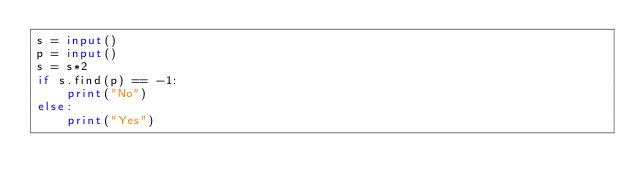Convert code to text. <code><loc_0><loc_0><loc_500><loc_500><_Python_>s = input()
p = input()
s = s*2
if s.find(p) == -1:
    print("No")
else:
    print("Yes")

</code> 